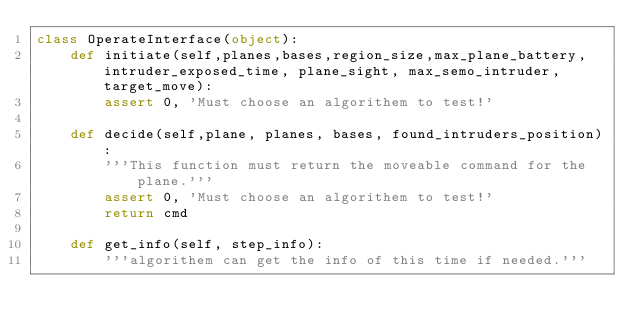<code> <loc_0><loc_0><loc_500><loc_500><_Python_>class OperateInterface(object):
    def initiate(self,planes,bases,region_size,max_plane_battery,intruder_exposed_time, plane_sight, max_semo_intruder, target_move):
        assert 0, 'Must choose an algorithem to test!'

    def decide(self,plane, planes, bases, found_intruders_position):
        '''This function must return the moveable command for the plane.'''
        assert 0, 'Must choose an algorithem to test!'
        return cmd

    def get_info(self, step_info):
        '''algorithem can get the info of this time if needed.'''
</code> 